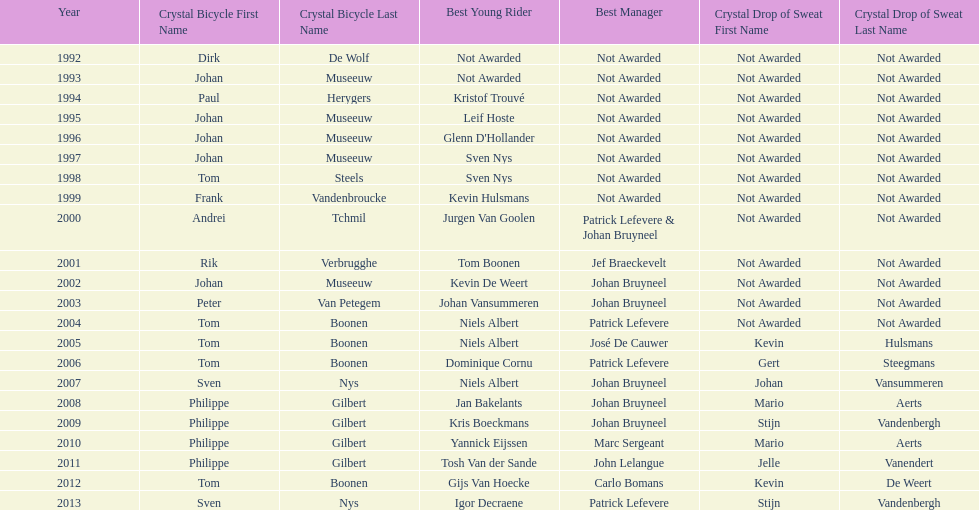What is the average number of times johan museeuw starred? 5. Parse the table in full. {'header': ['Year', 'Crystal Bicycle First Name', 'Crystal Bicycle Last Name', 'Best Young Rider', 'Best Manager', 'Crystal Drop of Sweat First Name', 'Crystal Drop of Sweat Last Name'], 'rows': [['1992', 'Dirk', 'De Wolf', 'Not Awarded', 'Not Awarded', 'Not Awarded', 'Not Awarded'], ['1993', 'Johan', 'Museeuw', 'Not Awarded', 'Not Awarded', 'Not Awarded', 'Not Awarded'], ['1994', 'Paul', 'Herygers', 'Kristof Trouvé', 'Not Awarded', 'Not Awarded', 'Not Awarded'], ['1995', 'Johan', 'Museeuw', 'Leif Hoste', 'Not Awarded', 'Not Awarded', 'Not Awarded'], ['1996', 'Johan', 'Museeuw', "Glenn D'Hollander", 'Not Awarded', 'Not Awarded', 'Not Awarded'], ['1997', 'Johan', 'Museeuw', 'Sven Nys', 'Not Awarded', 'Not Awarded', 'Not Awarded'], ['1998', 'Tom', 'Steels', 'Sven Nys', 'Not Awarded', 'Not Awarded', 'Not Awarded'], ['1999', 'Frank', 'Vandenbroucke', 'Kevin Hulsmans', 'Not Awarded', 'Not Awarded', 'Not Awarded'], ['2000', 'Andrei', 'Tchmil', 'Jurgen Van Goolen', 'Patrick Lefevere & Johan Bruyneel', 'Not Awarded', 'Not Awarded'], ['2001', 'Rik', 'Verbrugghe', 'Tom Boonen', 'Jef Braeckevelt', 'Not Awarded', 'Not Awarded'], ['2002', 'Johan', 'Museeuw', 'Kevin De Weert', 'Johan Bruyneel', 'Not Awarded', 'Not Awarded'], ['2003', 'Peter', 'Van Petegem', 'Johan Vansummeren', 'Johan Bruyneel', 'Not Awarded', 'Not Awarded'], ['2004', 'Tom', 'Boonen', 'Niels Albert', 'Patrick Lefevere', 'Not Awarded', 'Not Awarded'], ['2005', 'Tom', 'Boonen', 'Niels Albert', 'José De Cauwer', 'Kevin', 'Hulsmans'], ['2006', 'Tom', 'Boonen', 'Dominique Cornu', 'Patrick Lefevere', 'Gert', 'Steegmans'], ['2007', 'Sven', 'Nys', 'Niels Albert', 'Johan Bruyneel', 'Johan', 'Vansummeren'], ['2008', 'Philippe', 'Gilbert', 'Jan Bakelants', 'Johan Bruyneel', 'Mario', 'Aerts'], ['2009', 'Philippe', 'Gilbert', 'Kris Boeckmans', 'Johan Bruyneel', 'Stijn', 'Vandenbergh'], ['2010', 'Philippe', 'Gilbert', 'Yannick Eijssen', 'Marc Sergeant', 'Mario', 'Aerts'], ['2011', 'Philippe', 'Gilbert', 'Tosh Van der Sande', 'John Lelangue', 'Jelle', 'Vanendert'], ['2012', 'Tom', 'Boonen', 'Gijs Van Hoecke', 'Carlo Bomans', 'Kevin', 'De Weert'], ['2013', 'Sven', 'Nys', 'Igor Decraene', 'Patrick Lefevere', 'Stijn', 'Vandenbergh']]} 